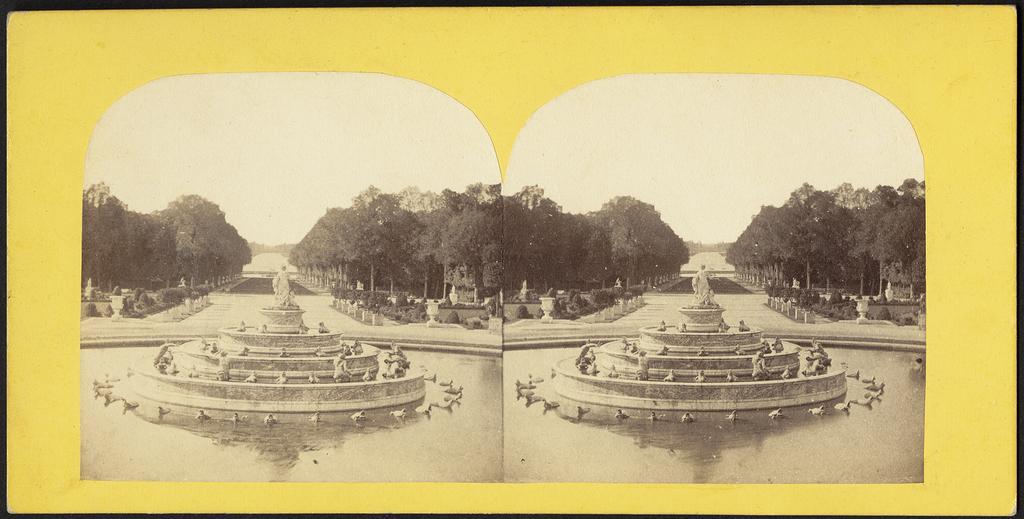Can you describe this image briefly? In this image I can see few trees on both-sides. In front I can see two fortunes,statues and water. The image is in black and white and border is in yellow and black color. 